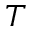<formula> <loc_0><loc_0><loc_500><loc_500>T</formula> 